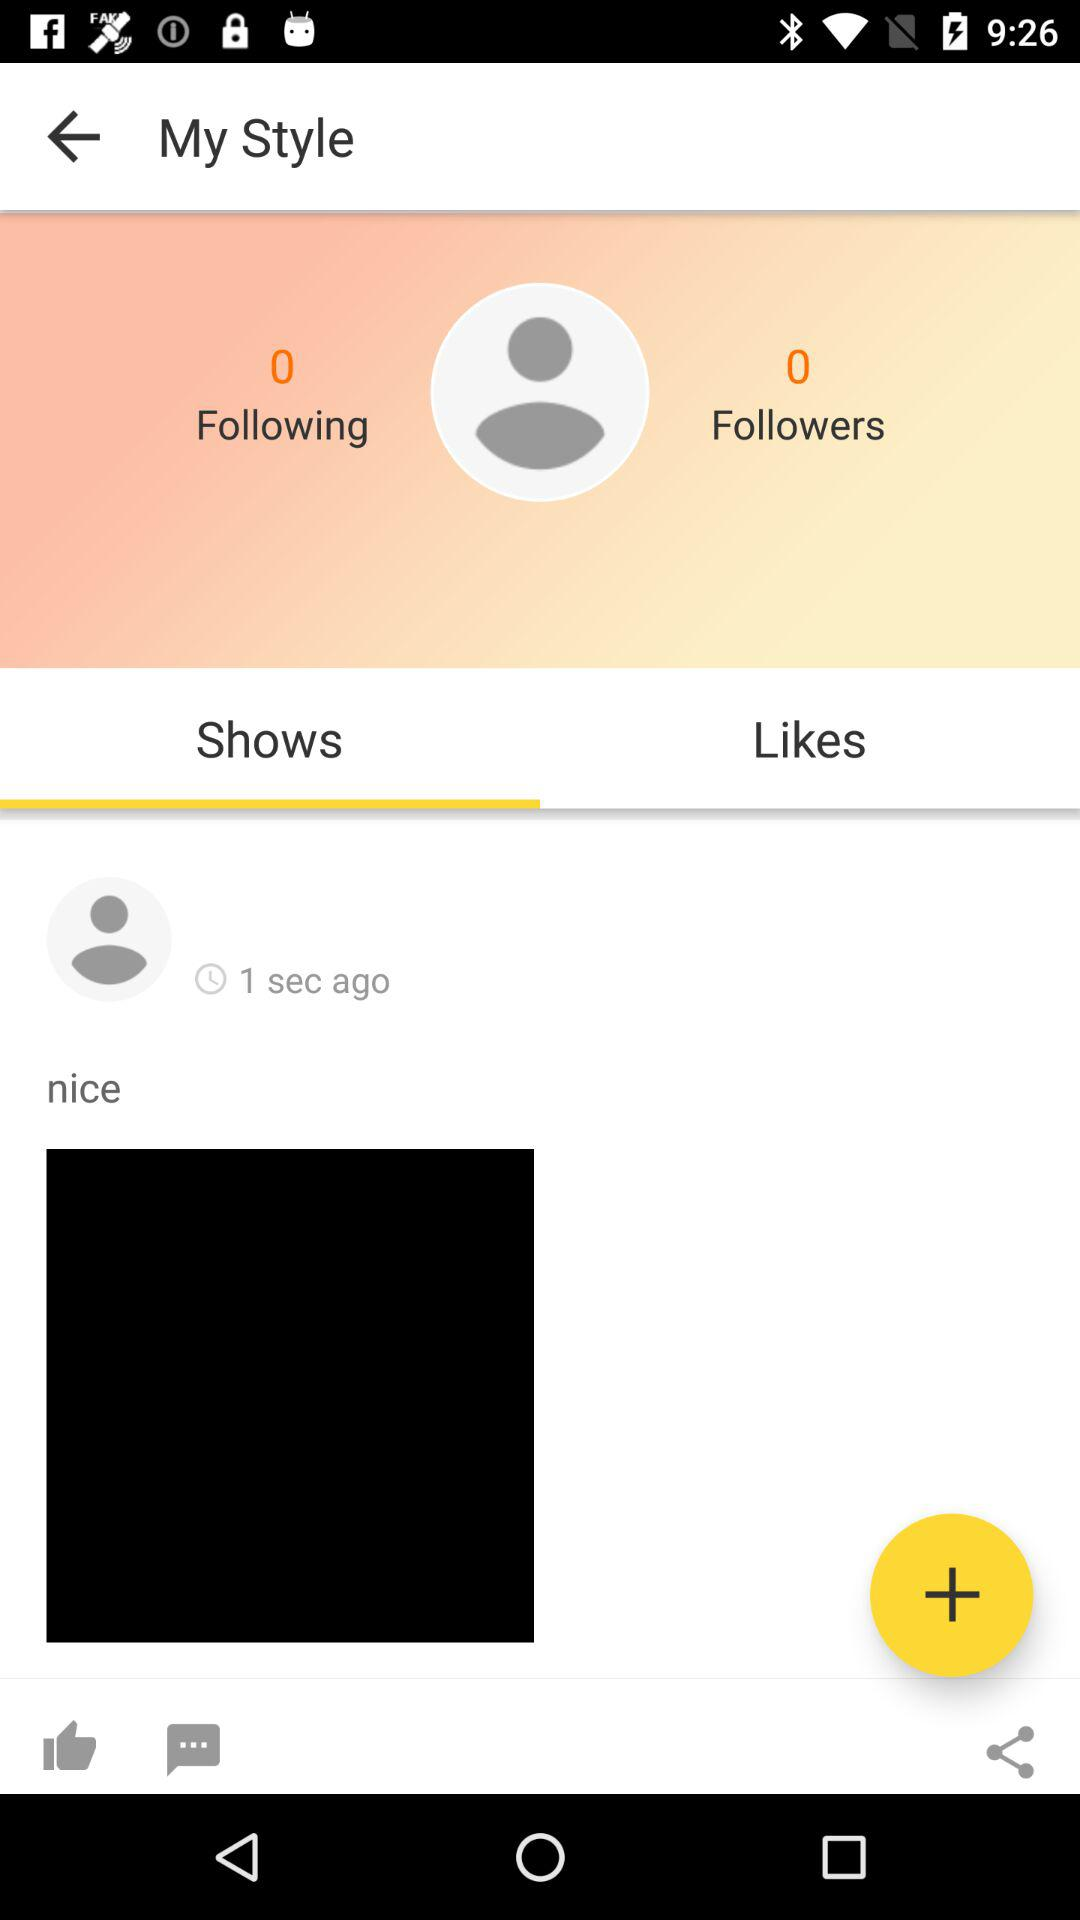What is the number of people who are following the user? The number of people who are following the user is 0. 